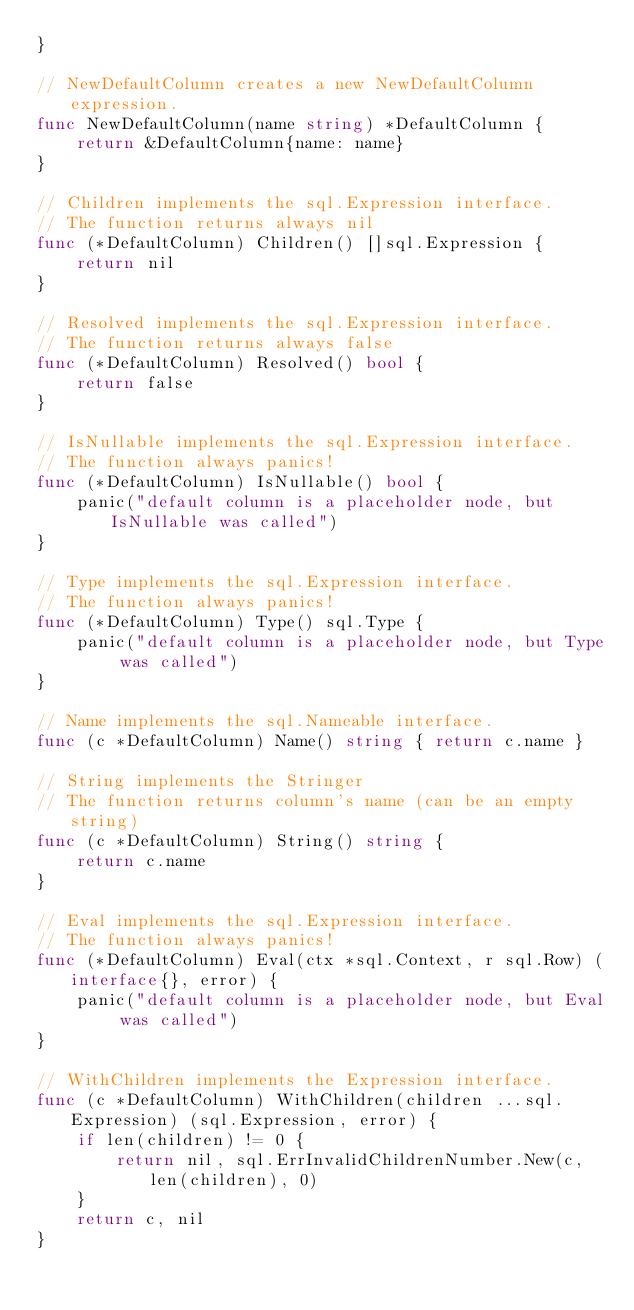Convert code to text. <code><loc_0><loc_0><loc_500><loc_500><_Go_>}

// NewDefaultColumn creates a new NewDefaultColumn expression.
func NewDefaultColumn(name string) *DefaultColumn {
	return &DefaultColumn{name: name}
}

// Children implements the sql.Expression interface.
// The function returns always nil
func (*DefaultColumn) Children() []sql.Expression {
	return nil
}

// Resolved implements the sql.Expression interface.
// The function returns always false
func (*DefaultColumn) Resolved() bool {
	return false
}

// IsNullable implements the sql.Expression interface.
// The function always panics!
func (*DefaultColumn) IsNullable() bool {
	panic("default column is a placeholder node, but IsNullable was called")
}

// Type implements the sql.Expression interface.
// The function always panics!
func (*DefaultColumn) Type() sql.Type {
	panic("default column is a placeholder node, but Type was called")
}

// Name implements the sql.Nameable interface.
func (c *DefaultColumn) Name() string { return c.name }

// String implements the Stringer
// The function returns column's name (can be an empty string)
func (c *DefaultColumn) String() string {
	return c.name
}

// Eval implements the sql.Expression interface.
// The function always panics!
func (*DefaultColumn) Eval(ctx *sql.Context, r sql.Row) (interface{}, error) {
	panic("default column is a placeholder node, but Eval was called")
}

// WithChildren implements the Expression interface.
func (c *DefaultColumn) WithChildren(children ...sql.Expression) (sql.Expression, error) {
	if len(children) != 0 {
		return nil, sql.ErrInvalidChildrenNumber.New(c, len(children), 0)
	}
	return c, nil
}
</code> 